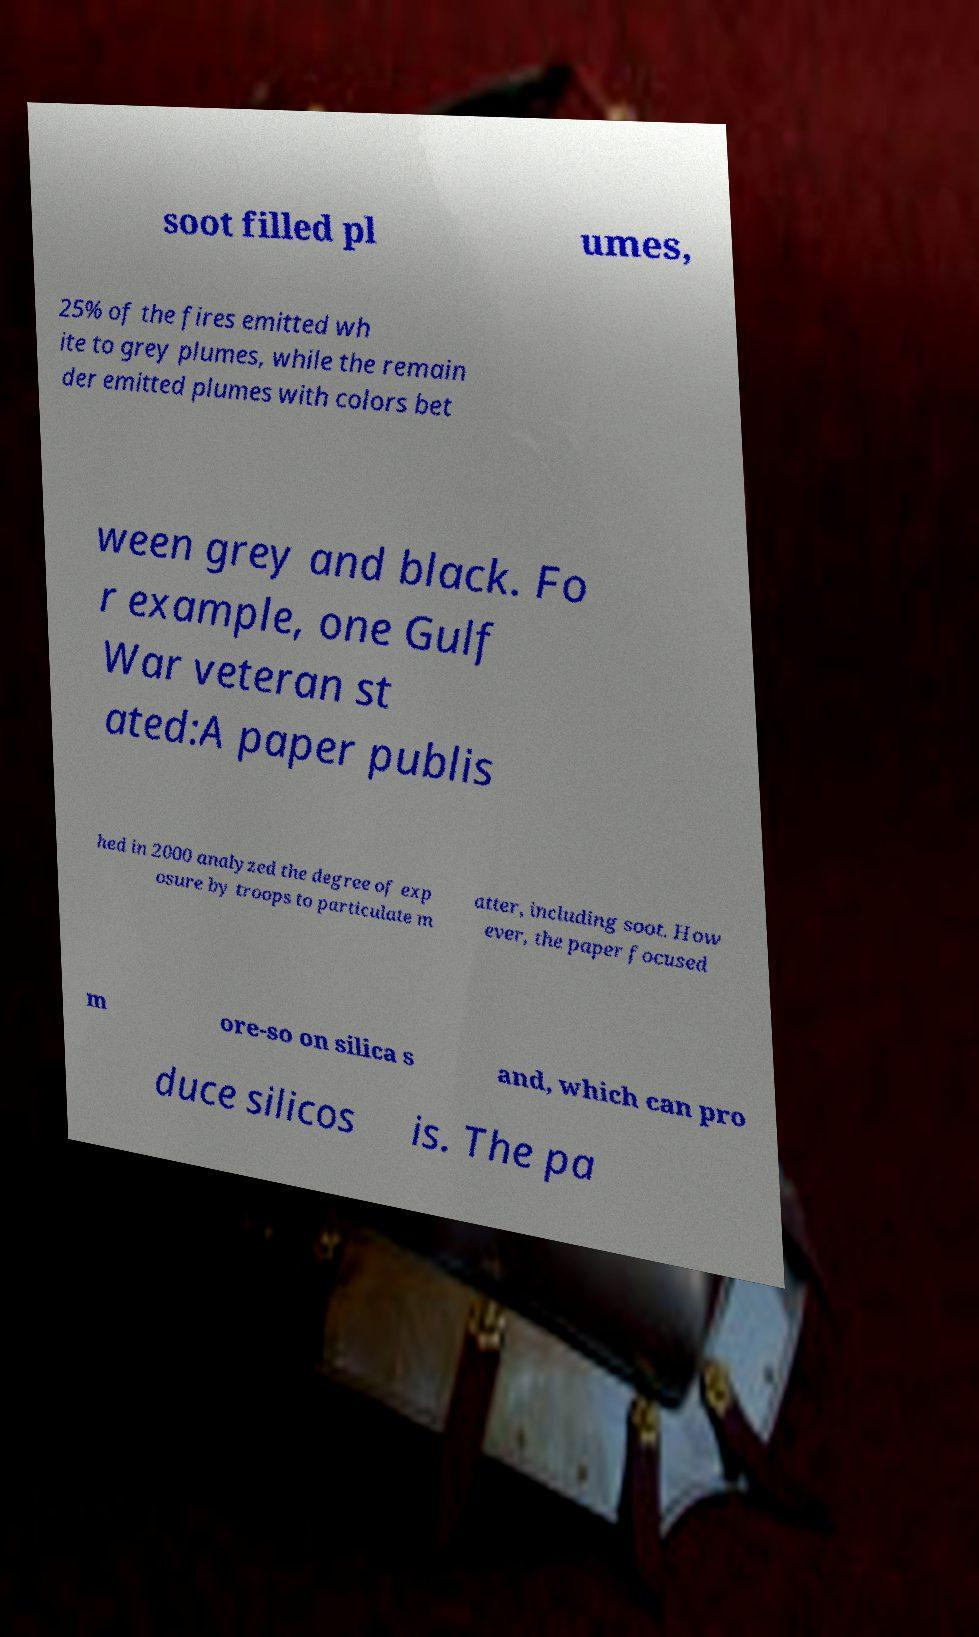Could you extract and type out the text from this image? soot filled pl umes, 25% of the fires emitted wh ite to grey plumes, while the remain der emitted plumes with colors bet ween grey and black. Fo r example, one Gulf War veteran st ated:A paper publis hed in 2000 analyzed the degree of exp osure by troops to particulate m atter, including soot. How ever, the paper focused m ore-so on silica s and, which can pro duce silicos is. The pa 